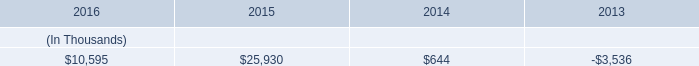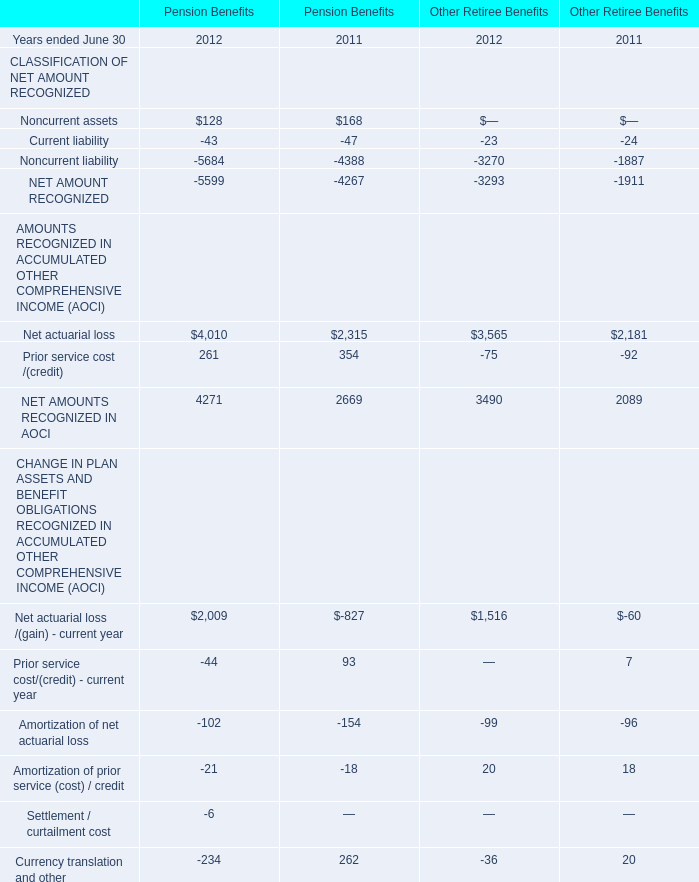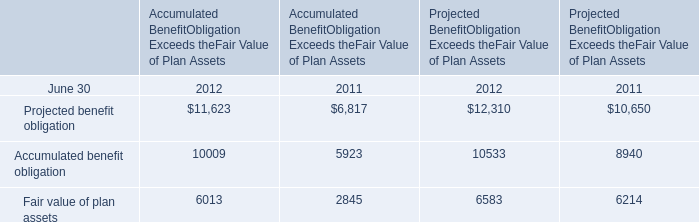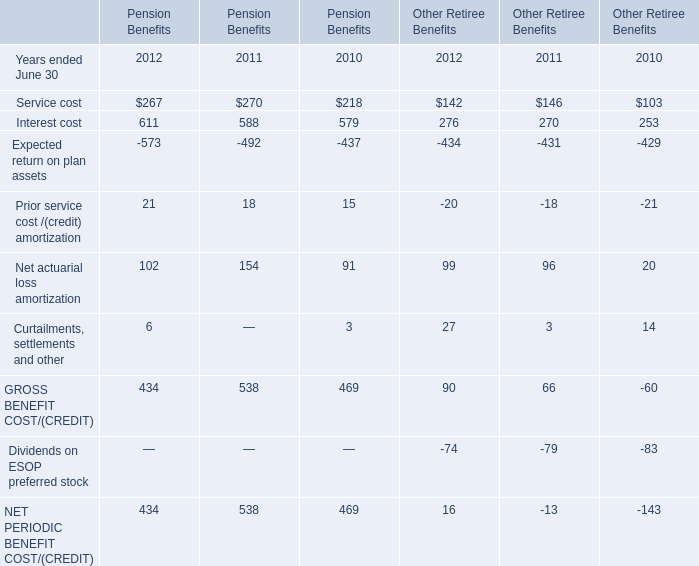What was the total amount of Service cost excluding those Service cost greater than 270 in Pension Benefits 
Computations: (267 + 218)
Answer: 485.0. 